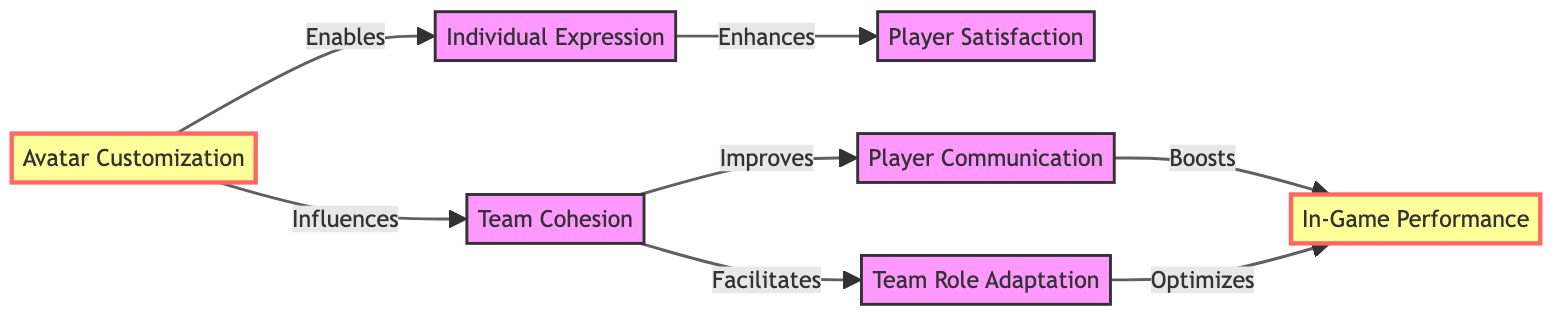What is the first node in the diagram? The first node in the diagram is labeled "Avatar Customization." It is placed at the top of the flowchart and connects to various other nodes.
Answer: Avatar Customization How many nodes are present in the diagram? By counting the labeled nodes in the diagram, we see a total of seven distinct nodes connected by arrows, which show their relationships.
Answer: 7 What relationship exists between "Avatar Customization" and "Individual Expression"? The diagram indicates that "Avatar Customization" enables "Individual Expression," showing a direct influence from one node to the other.
Answer: Enables Which node is influenced by "Team Cohesion"? The diagram shows that "Team Cohesion" improves "Player Communication," indicating that it positively affects the latter.
Answer: Player Communication What is the resulting effect of "Player Communication" on "In-Game Performance"? According to the diagram, "Player Communication" boosts "In-Game Performance," implying a direct positive relationship.
Answer: Boosts How does "Team Role Adaptation" affect "In-Game Performance"? The flowchart shows that "Team Role Adaptation" optimizes "In-Game Performance," indicating a beneficial outcome from effective adaptation of roles.
Answer: Optimizes What is the direct relationship between "Individual Expression" and "Player Satisfaction"? The diagram states that "Individual Expression" enhances "Player Satisfaction," demonstrating a positive effect on player contentment.
Answer: Enhances Which node does "Team Cohesion" facilitate? In the diagram, "Team Cohesion" is shown to facilitate "Team Role Adaptation," connecting these two concepts together.
Answer: Team Role Adaptation What effect does "Avatar Customization" have on "Team Cohesion"? The diagram shows that "Avatar Customization" influences "Team Cohesion," suggesting it plays a role in determining the strength of team dynamics.
Answer: Influences 